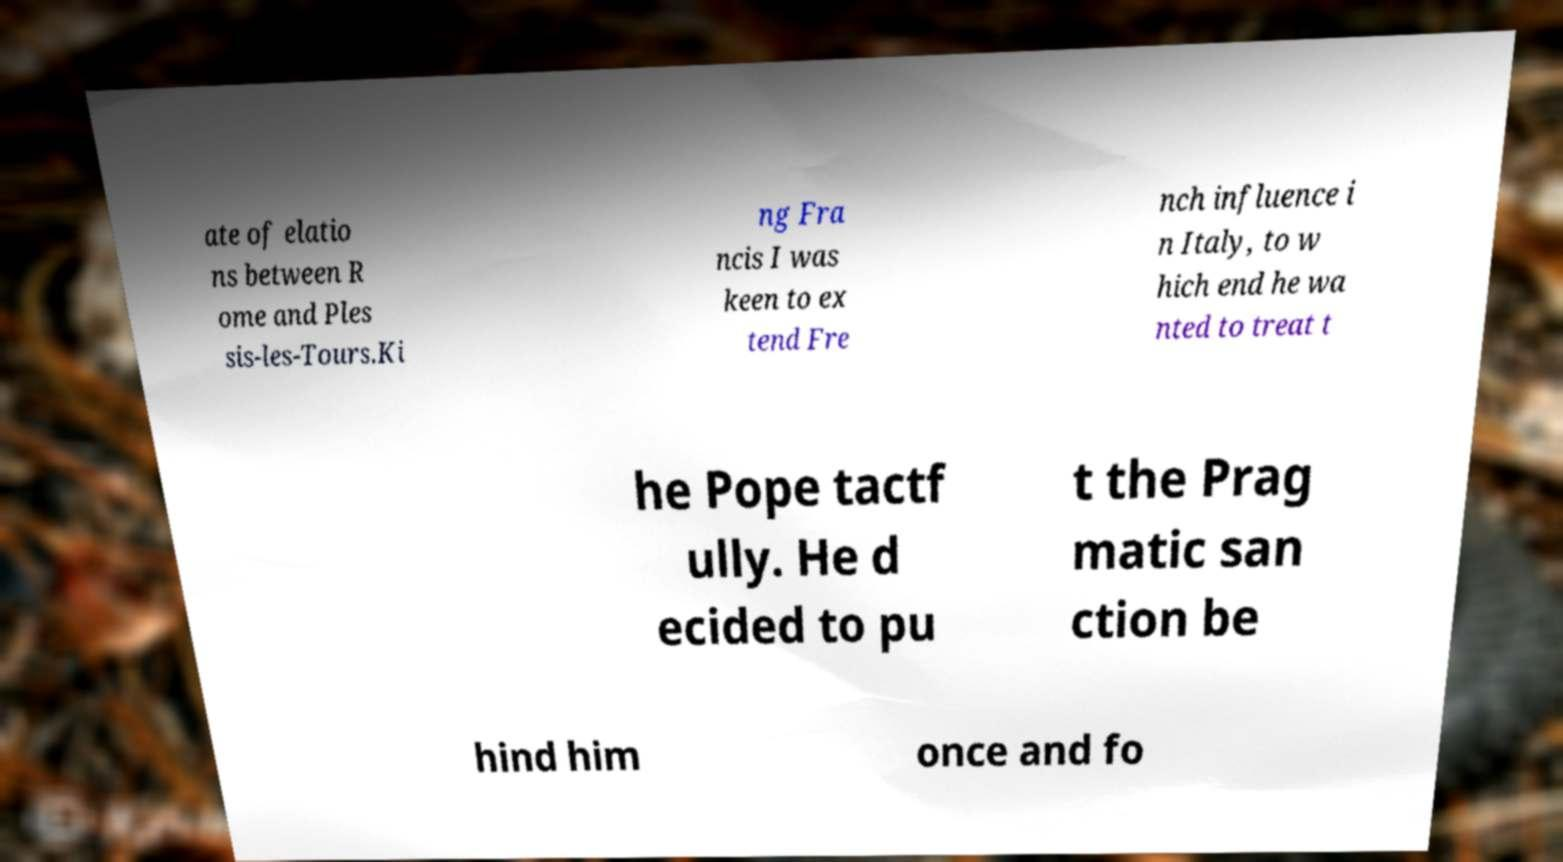What messages or text are displayed in this image? I need them in a readable, typed format. ate of elatio ns between R ome and Ples sis-les-Tours.Ki ng Fra ncis I was keen to ex tend Fre nch influence i n Italy, to w hich end he wa nted to treat t he Pope tactf ully. He d ecided to pu t the Prag matic san ction be hind him once and fo 